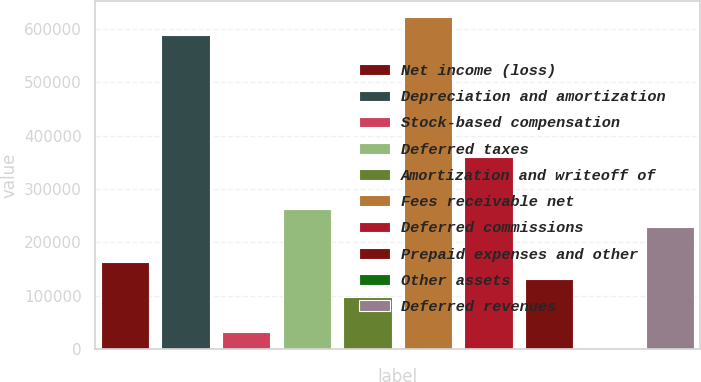<chart> <loc_0><loc_0><loc_500><loc_500><bar_chart><fcel>Net income (loss)<fcel>Depreciation and amortization<fcel>Stock-based compensation<fcel>Deferred taxes<fcel>Amortization and writeoff of<fcel>Fees receivable net<fcel>Deferred commissions<fcel>Prepaid expenses and other<fcel>Other assets<fcel>Deferred revenues<nl><fcel>163556<fcel>588510<fcel>32801.7<fcel>261623<fcel>98179.1<fcel>621198<fcel>359689<fcel>130868<fcel>113<fcel>228934<nl></chart> 